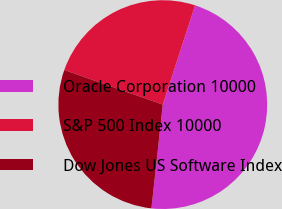<chart> <loc_0><loc_0><loc_500><loc_500><pie_chart><fcel>Oracle Corporation 10000<fcel>S&P 500 Index 10000<fcel>Dow Jones US Software Index<nl><fcel>46.73%<fcel>24.64%<fcel>28.64%<nl></chart> 